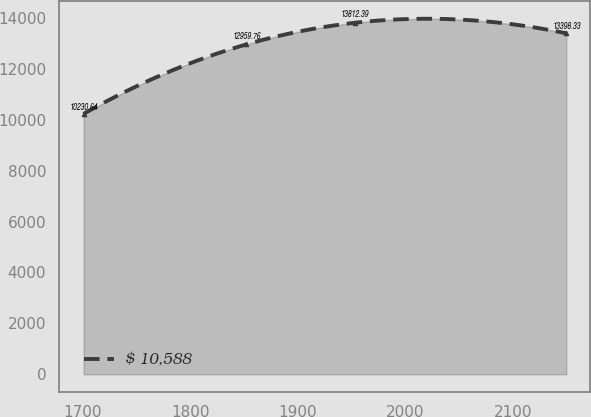Convert chart. <chart><loc_0><loc_0><loc_500><loc_500><line_chart><ecel><fcel>$ 10,588<nl><fcel>1700.61<fcel>10230.6<nl><fcel>1851.99<fcel>12959.8<nl><fcel>1953.21<fcel>13812.4<nl><fcel>2149.74<fcel>13398.3<nl></chart> 